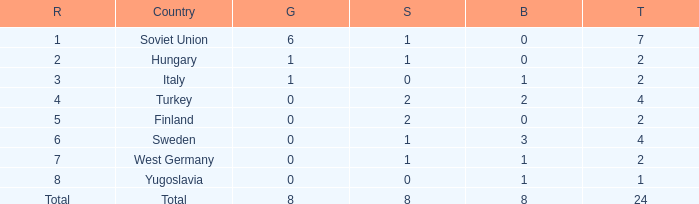What is the sum of Total, when Rank is 8, and when Bronze is less than 1? None. 